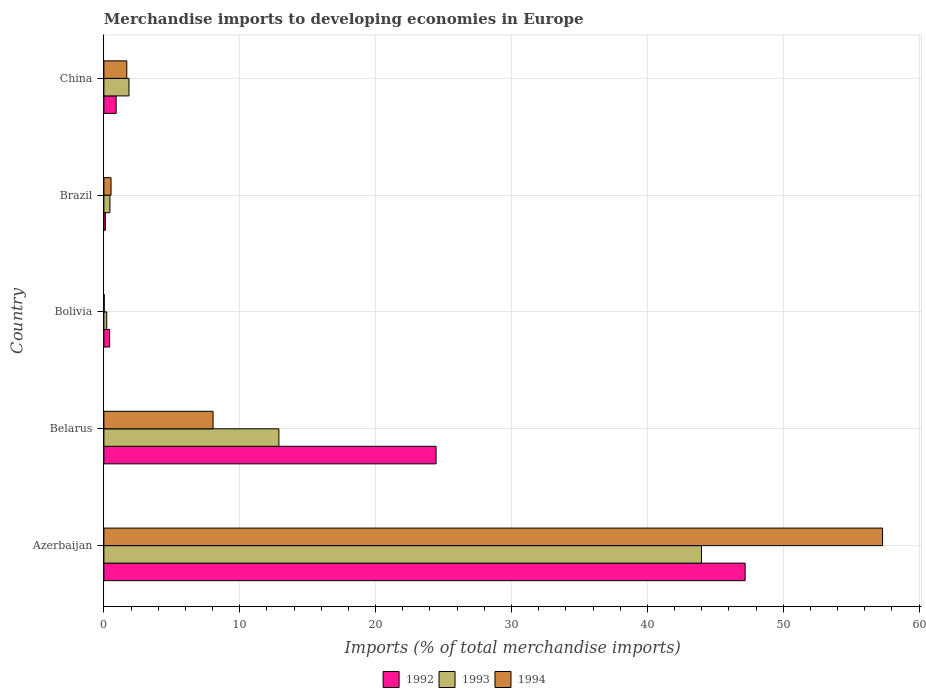How many groups of bars are there?
Provide a short and direct response. 5. How many bars are there on the 4th tick from the top?
Your answer should be compact. 3. What is the label of the 5th group of bars from the top?
Your answer should be very brief. Azerbaijan. In how many cases, is the number of bars for a given country not equal to the number of legend labels?
Your answer should be compact. 0. What is the percentage total merchandise imports in 1993 in Bolivia?
Provide a short and direct response. 0.21. Across all countries, what is the maximum percentage total merchandise imports in 1994?
Provide a succinct answer. 57.31. Across all countries, what is the minimum percentage total merchandise imports in 1992?
Offer a terse response. 0.11. In which country was the percentage total merchandise imports in 1993 maximum?
Your answer should be compact. Azerbaijan. What is the total percentage total merchandise imports in 1994 in the graph?
Give a very brief answer. 67.58. What is the difference between the percentage total merchandise imports in 1992 in Belarus and that in Brazil?
Give a very brief answer. 24.34. What is the difference between the percentage total merchandise imports in 1993 in Bolivia and the percentage total merchandise imports in 1994 in Brazil?
Your answer should be compact. -0.32. What is the average percentage total merchandise imports in 1992 per country?
Provide a short and direct response. 14.62. What is the difference between the percentage total merchandise imports in 1993 and percentage total merchandise imports in 1994 in Azerbaijan?
Your answer should be very brief. -13.33. In how many countries, is the percentage total merchandise imports in 1992 greater than 12 %?
Your response must be concise. 2. What is the ratio of the percentage total merchandise imports in 1994 in Azerbaijan to that in Belarus?
Provide a short and direct response. 7.13. Is the percentage total merchandise imports in 1994 in Bolivia less than that in China?
Give a very brief answer. Yes. What is the difference between the highest and the second highest percentage total merchandise imports in 1992?
Your answer should be very brief. 22.75. What is the difference between the highest and the lowest percentage total merchandise imports in 1994?
Ensure brevity in your answer.  57.29. In how many countries, is the percentage total merchandise imports in 1993 greater than the average percentage total merchandise imports in 1993 taken over all countries?
Give a very brief answer. 2. Is it the case that in every country, the sum of the percentage total merchandise imports in 1993 and percentage total merchandise imports in 1994 is greater than the percentage total merchandise imports in 1992?
Your answer should be very brief. No. How many bars are there?
Provide a succinct answer. 15. Does the graph contain any zero values?
Provide a succinct answer. No. Does the graph contain grids?
Keep it short and to the point. Yes. Where does the legend appear in the graph?
Provide a short and direct response. Bottom center. What is the title of the graph?
Provide a short and direct response. Merchandise imports to developing economies in Europe. Does "2007" appear as one of the legend labels in the graph?
Your response must be concise. No. What is the label or title of the X-axis?
Your answer should be compact. Imports (% of total merchandise imports). What is the Imports (% of total merchandise imports) in 1992 in Azerbaijan?
Ensure brevity in your answer.  47.2. What is the Imports (% of total merchandise imports) in 1993 in Azerbaijan?
Provide a short and direct response. 43.99. What is the Imports (% of total merchandise imports) in 1994 in Azerbaijan?
Ensure brevity in your answer.  57.31. What is the Imports (% of total merchandise imports) of 1992 in Belarus?
Provide a short and direct response. 24.45. What is the Imports (% of total merchandise imports) in 1993 in Belarus?
Make the answer very short. 12.88. What is the Imports (% of total merchandise imports) of 1994 in Belarus?
Ensure brevity in your answer.  8.04. What is the Imports (% of total merchandise imports) of 1992 in Bolivia?
Your answer should be compact. 0.42. What is the Imports (% of total merchandise imports) in 1993 in Bolivia?
Your answer should be very brief. 0.21. What is the Imports (% of total merchandise imports) of 1994 in Bolivia?
Ensure brevity in your answer.  0.02. What is the Imports (% of total merchandise imports) of 1992 in Brazil?
Provide a short and direct response. 0.11. What is the Imports (% of total merchandise imports) of 1993 in Brazil?
Offer a very short reply. 0.44. What is the Imports (% of total merchandise imports) of 1994 in Brazil?
Offer a terse response. 0.52. What is the Imports (% of total merchandise imports) of 1992 in China?
Your answer should be very brief. 0.9. What is the Imports (% of total merchandise imports) of 1993 in China?
Your answer should be compact. 1.85. What is the Imports (% of total merchandise imports) in 1994 in China?
Offer a very short reply. 1.68. Across all countries, what is the maximum Imports (% of total merchandise imports) of 1992?
Offer a very short reply. 47.2. Across all countries, what is the maximum Imports (% of total merchandise imports) of 1993?
Provide a short and direct response. 43.99. Across all countries, what is the maximum Imports (% of total merchandise imports) of 1994?
Provide a succinct answer. 57.31. Across all countries, what is the minimum Imports (% of total merchandise imports) in 1992?
Ensure brevity in your answer.  0.11. Across all countries, what is the minimum Imports (% of total merchandise imports) in 1993?
Make the answer very short. 0.21. Across all countries, what is the minimum Imports (% of total merchandise imports) in 1994?
Offer a terse response. 0.02. What is the total Imports (% of total merchandise imports) in 1992 in the graph?
Ensure brevity in your answer.  73.08. What is the total Imports (% of total merchandise imports) in 1993 in the graph?
Provide a succinct answer. 59.37. What is the total Imports (% of total merchandise imports) in 1994 in the graph?
Your response must be concise. 67.58. What is the difference between the Imports (% of total merchandise imports) in 1992 in Azerbaijan and that in Belarus?
Keep it short and to the point. 22.75. What is the difference between the Imports (% of total merchandise imports) of 1993 in Azerbaijan and that in Belarus?
Your response must be concise. 31.11. What is the difference between the Imports (% of total merchandise imports) of 1994 in Azerbaijan and that in Belarus?
Your answer should be compact. 49.28. What is the difference between the Imports (% of total merchandise imports) in 1992 in Azerbaijan and that in Bolivia?
Offer a very short reply. 46.78. What is the difference between the Imports (% of total merchandise imports) in 1993 in Azerbaijan and that in Bolivia?
Offer a very short reply. 43.78. What is the difference between the Imports (% of total merchandise imports) in 1994 in Azerbaijan and that in Bolivia?
Your response must be concise. 57.29. What is the difference between the Imports (% of total merchandise imports) of 1992 in Azerbaijan and that in Brazil?
Your response must be concise. 47.09. What is the difference between the Imports (% of total merchandise imports) in 1993 in Azerbaijan and that in Brazil?
Provide a succinct answer. 43.54. What is the difference between the Imports (% of total merchandise imports) of 1994 in Azerbaijan and that in Brazil?
Keep it short and to the point. 56.79. What is the difference between the Imports (% of total merchandise imports) of 1992 in Azerbaijan and that in China?
Your answer should be compact. 46.3. What is the difference between the Imports (% of total merchandise imports) in 1993 in Azerbaijan and that in China?
Offer a very short reply. 42.14. What is the difference between the Imports (% of total merchandise imports) of 1994 in Azerbaijan and that in China?
Provide a short and direct response. 55.63. What is the difference between the Imports (% of total merchandise imports) of 1992 in Belarus and that in Bolivia?
Provide a short and direct response. 24.03. What is the difference between the Imports (% of total merchandise imports) of 1993 in Belarus and that in Bolivia?
Keep it short and to the point. 12.67. What is the difference between the Imports (% of total merchandise imports) of 1994 in Belarus and that in Bolivia?
Ensure brevity in your answer.  8.01. What is the difference between the Imports (% of total merchandise imports) in 1992 in Belarus and that in Brazil?
Provide a short and direct response. 24.34. What is the difference between the Imports (% of total merchandise imports) of 1993 in Belarus and that in Brazil?
Offer a terse response. 12.44. What is the difference between the Imports (% of total merchandise imports) in 1994 in Belarus and that in Brazil?
Offer a terse response. 7.51. What is the difference between the Imports (% of total merchandise imports) in 1992 in Belarus and that in China?
Your answer should be compact. 23.55. What is the difference between the Imports (% of total merchandise imports) of 1993 in Belarus and that in China?
Your answer should be compact. 11.03. What is the difference between the Imports (% of total merchandise imports) in 1994 in Belarus and that in China?
Offer a terse response. 6.35. What is the difference between the Imports (% of total merchandise imports) of 1992 in Bolivia and that in Brazil?
Offer a very short reply. 0.32. What is the difference between the Imports (% of total merchandise imports) of 1993 in Bolivia and that in Brazil?
Offer a terse response. -0.24. What is the difference between the Imports (% of total merchandise imports) of 1994 in Bolivia and that in Brazil?
Your response must be concise. -0.5. What is the difference between the Imports (% of total merchandise imports) of 1992 in Bolivia and that in China?
Ensure brevity in your answer.  -0.48. What is the difference between the Imports (% of total merchandise imports) in 1993 in Bolivia and that in China?
Your response must be concise. -1.64. What is the difference between the Imports (% of total merchandise imports) in 1994 in Bolivia and that in China?
Give a very brief answer. -1.66. What is the difference between the Imports (% of total merchandise imports) in 1992 in Brazil and that in China?
Your answer should be compact. -0.8. What is the difference between the Imports (% of total merchandise imports) in 1993 in Brazil and that in China?
Offer a very short reply. -1.4. What is the difference between the Imports (% of total merchandise imports) in 1994 in Brazil and that in China?
Make the answer very short. -1.16. What is the difference between the Imports (% of total merchandise imports) in 1992 in Azerbaijan and the Imports (% of total merchandise imports) in 1993 in Belarus?
Keep it short and to the point. 34.32. What is the difference between the Imports (% of total merchandise imports) in 1992 in Azerbaijan and the Imports (% of total merchandise imports) in 1994 in Belarus?
Your answer should be compact. 39.16. What is the difference between the Imports (% of total merchandise imports) of 1993 in Azerbaijan and the Imports (% of total merchandise imports) of 1994 in Belarus?
Your answer should be very brief. 35.95. What is the difference between the Imports (% of total merchandise imports) in 1992 in Azerbaijan and the Imports (% of total merchandise imports) in 1993 in Bolivia?
Offer a very short reply. 46.99. What is the difference between the Imports (% of total merchandise imports) of 1992 in Azerbaijan and the Imports (% of total merchandise imports) of 1994 in Bolivia?
Offer a very short reply. 47.17. What is the difference between the Imports (% of total merchandise imports) in 1993 in Azerbaijan and the Imports (% of total merchandise imports) in 1994 in Bolivia?
Your response must be concise. 43.96. What is the difference between the Imports (% of total merchandise imports) of 1992 in Azerbaijan and the Imports (% of total merchandise imports) of 1993 in Brazil?
Your answer should be compact. 46.75. What is the difference between the Imports (% of total merchandise imports) of 1992 in Azerbaijan and the Imports (% of total merchandise imports) of 1994 in Brazil?
Offer a terse response. 46.67. What is the difference between the Imports (% of total merchandise imports) of 1993 in Azerbaijan and the Imports (% of total merchandise imports) of 1994 in Brazil?
Make the answer very short. 43.46. What is the difference between the Imports (% of total merchandise imports) of 1992 in Azerbaijan and the Imports (% of total merchandise imports) of 1993 in China?
Your response must be concise. 45.35. What is the difference between the Imports (% of total merchandise imports) in 1992 in Azerbaijan and the Imports (% of total merchandise imports) in 1994 in China?
Provide a succinct answer. 45.51. What is the difference between the Imports (% of total merchandise imports) of 1993 in Azerbaijan and the Imports (% of total merchandise imports) of 1994 in China?
Offer a very short reply. 42.3. What is the difference between the Imports (% of total merchandise imports) in 1992 in Belarus and the Imports (% of total merchandise imports) in 1993 in Bolivia?
Keep it short and to the point. 24.24. What is the difference between the Imports (% of total merchandise imports) of 1992 in Belarus and the Imports (% of total merchandise imports) of 1994 in Bolivia?
Your answer should be compact. 24.43. What is the difference between the Imports (% of total merchandise imports) in 1993 in Belarus and the Imports (% of total merchandise imports) in 1994 in Bolivia?
Provide a short and direct response. 12.86. What is the difference between the Imports (% of total merchandise imports) of 1992 in Belarus and the Imports (% of total merchandise imports) of 1993 in Brazil?
Ensure brevity in your answer.  24.01. What is the difference between the Imports (% of total merchandise imports) in 1992 in Belarus and the Imports (% of total merchandise imports) in 1994 in Brazil?
Offer a very short reply. 23.93. What is the difference between the Imports (% of total merchandise imports) in 1993 in Belarus and the Imports (% of total merchandise imports) in 1994 in Brazil?
Ensure brevity in your answer.  12.36. What is the difference between the Imports (% of total merchandise imports) of 1992 in Belarus and the Imports (% of total merchandise imports) of 1993 in China?
Offer a terse response. 22.6. What is the difference between the Imports (% of total merchandise imports) of 1992 in Belarus and the Imports (% of total merchandise imports) of 1994 in China?
Provide a short and direct response. 22.77. What is the difference between the Imports (% of total merchandise imports) in 1993 in Belarus and the Imports (% of total merchandise imports) in 1994 in China?
Give a very brief answer. 11.2. What is the difference between the Imports (% of total merchandise imports) of 1992 in Bolivia and the Imports (% of total merchandise imports) of 1993 in Brazil?
Offer a very short reply. -0.02. What is the difference between the Imports (% of total merchandise imports) of 1992 in Bolivia and the Imports (% of total merchandise imports) of 1994 in Brazil?
Your response must be concise. -0.1. What is the difference between the Imports (% of total merchandise imports) in 1993 in Bolivia and the Imports (% of total merchandise imports) in 1994 in Brazil?
Make the answer very short. -0.32. What is the difference between the Imports (% of total merchandise imports) of 1992 in Bolivia and the Imports (% of total merchandise imports) of 1993 in China?
Your answer should be compact. -1.42. What is the difference between the Imports (% of total merchandise imports) in 1992 in Bolivia and the Imports (% of total merchandise imports) in 1994 in China?
Provide a succinct answer. -1.26. What is the difference between the Imports (% of total merchandise imports) of 1993 in Bolivia and the Imports (% of total merchandise imports) of 1994 in China?
Your answer should be compact. -1.48. What is the difference between the Imports (% of total merchandise imports) in 1992 in Brazil and the Imports (% of total merchandise imports) in 1993 in China?
Offer a terse response. -1.74. What is the difference between the Imports (% of total merchandise imports) in 1992 in Brazil and the Imports (% of total merchandise imports) in 1994 in China?
Provide a short and direct response. -1.58. What is the difference between the Imports (% of total merchandise imports) of 1993 in Brazil and the Imports (% of total merchandise imports) of 1994 in China?
Provide a succinct answer. -1.24. What is the average Imports (% of total merchandise imports) in 1992 per country?
Provide a succinct answer. 14.62. What is the average Imports (% of total merchandise imports) of 1993 per country?
Your answer should be compact. 11.87. What is the average Imports (% of total merchandise imports) in 1994 per country?
Offer a terse response. 13.52. What is the difference between the Imports (% of total merchandise imports) in 1992 and Imports (% of total merchandise imports) in 1993 in Azerbaijan?
Make the answer very short. 3.21. What is the difference between the Imports (% of total merchandise imports) in 1992 and Imports (% of total merchandise imports) in 1994 in Azerbaijan?
Your response must be concise. -10.11. What is the difference between the Imports (% of total merchandise imports) in 1993 and Imports (% of total merchandise imports) in 1994 in Azerbaijan?
Provide a succinct answer. -13.33. What is the difference between the Imports (% of total merchandise imports) in 1992 and Imports (% of total merchandise imports) in 1993 in Belarus?
Ensure brevity in your answer.  11.57. What is the difference between the Imports (% of total merchandise imports) in 1992 and Imports (% of total merchandise imports) in 1994 in Belarus?
Give a very brief answer. 16.41. What is the difference between the Imports (% of total merchandise imports) of 1993 and Imports (% of total merchandise imports) of 1994 in Belarus?
Keep it short and to the point. 4.84. What is the difference between the Imports (% of total merchandise imports) of 1992 and Imports (% of total merchandise imports) of 1993 in Bolivia?
Offer a terse response. 0.22. What is the difference between the Imports (% of total merchandise imports) in 1992 and Imports (% of total merchandise imports) in 1994 in Bolivia?
Ensure brevity in your answer.  0.4. What is the difference between the Imports (% of total merchandise imports) of 1993 and Imports (% of total merchandise imports) of 1994 in Bolivia?
Your answer should be compact. 0.18. What is the difference between the Imports (% of total merchandise imports) of 1992 and Imports (% of total merchandise imports) of 1993 in Brazil?
Keep it short and to the point. -0.34. What is the difference between the Imports (% of total merchandise imports) of 1992 and Imports (% of total merchandise imports) of 1994 in Brazil?
Provide a succinct answer. -0.42. What is the difference between the Imports (% of total merchandise imports) of 1993 and Imports (% of total merchandise imports) of 1994 in Brazil?
Keep it short and to the point. -0.08. What is the difference between the Imports (% of total merchandise imports) of 1992 and Imports (% of total merchandise imports) of 1993 in China?
Your answer should be very brief. -0.94. What is the difference between the Imports (% of total merchandise imports) in 1992 and Imports (% of total merchandise imports) in 1994 in China?
Your response must be concise. -0.78. What is the difference between the Imports (% of total merchandise imports) of 1993 and Imports (% of total merchandise imports) of 1994 in China?
Keep it short and to the point. 0.16. What is the ratio of the Imports (% of total merchandise imports) in 1992 in Azerbaijan to that in Belarus?
Ensure brevity in your answer.  1.93. What is the ratio of the Imports (% of total merchandise imports) of 1993 in Azerbaijan to that in Belarus?
Your answer should be compact. 3.42. What is the ratio of the Imports (% of total merchandise imports) in 1994 in Azerbaijan to that in Belarus?
Your response must be concise. 7.13. What is the ratio of the Imports (% of total merchandise imports) of 1992 in Azerbaijan to that in Bolivia?
Provide a succinct answer. 111.66. What is the ratio of the Imports (% of total merchandise imports) in 1993 in Azerbaijan to that in Bolivia?
Provide a succinct answer. 212.06. What is the ratio of the Imports (% of total merchandise imports) of 1994 in Azerbaijan to that in Bolivia?
Provide a succinct answer. 2324.83. What is the ratio of the Imports (% of total merchandise imports) of 1992 in Azerbaijan to that in Brazil?
Keep it short and to the point. 439.5. What is the ratio of the Imports (% of total merchandise imports) in 1993 in Azerbaijan to that in Brazil?
Make the answer very short. 98.86. What is the ratio of the Imports (% of total merchandise imports) in 1994 in Azerbaijan to that in Brazil?
Keep it short and to the point. 109.17. What is the ratio of the Imports (% of total merchandise imports) in 1992 in Azerbaijan to that in China?
Keep it short and to the point. 52.3. What is the ratio of the Imports (% of total merchandise imports) in 1993 in Azerbaijan to that in China?
Give a very brief answer. 23.81. What is the ratio of the Imports (% of total merchandise imports) of 1994 in Azerbaijan to that in China?
Your response must be concise. 34.03. What is the ratio of the Imports (% of total merchandise imports) of 1992 in Belarus to that in Bolivia?
Your response must be concise. 57.84. What is the ratio of the Imports (% of total merchandise imports) of 1993 in Belarus to that in Bolivia?
Your response must be concise. 62.09. What is the ratio of the Imports (% of total merchandise imports) in 1994 in Belarus to that in Bolivia?
Provide a short and direct response. 326.01. What is the ratio of the Imports (% of total merchandise imports) of 1992 in Belarus to that in Brazil?
Make the answer very short. 227.68. What is the ratio of the Imports (% of total merchandise imports) of 1993 in Belarus to that in Brazil?
Your answer should be very brief. 28.95. What is the ratio of the Imports (% of total merchandise imports) of 1994 in Belarus to that in Brazil?
Your response must be concise. 15.31. What is the ratio of the Imports (% of total merchandise imports) in 1992 in Belarus to that in China?
Provide a short and direct response. 27.09. What is the ratio of the Imports (% of total merchandise imports) in 1993 in Belarus to that in China?
Offer a terse response. 6.97. What is the ratio of the Imports (% of total merchandise imports) in 1994 in Belarus to that in China?
Your answer should be compact. 4.77. What is the ratio of the Imports (% of total merchandise imports) of 1992 in Bolivia to that in Brazil?
Keep it short and to the point. 3.94. What is the ratio of the Imports (% of total merchandise imports) of 1993 in Bolivia to that in Brazil?
Offer a very short reply. 0.47. What is the ratio of the Imports (% of total merchandise imports) of 1994 in Bolivia to that in Brazil?
Your answer should be very brief. 0.05. What is the ratio of the Imports (% of total merchandise imports) in 1992 in Bolivia to that in China?
Give a very brief answer. 0.47. What is the ratio of the Imports (% of total merchandise imports) of 1993 in Bolivia to that in China?
Make the answer very short. 0.11. What is the ratio of the Imports (% of total merchandise imports) of 1994 in Bolivia to that in China?
Ensure brevity in your answer.  0.01. What is the ratio of the Imports (% of total merchandise imports) in 1992 in Brazil to that in China?
Your answer should be compact. 0.12. What is the ratio of the Imports (% of total merchandise imports) of 1993 in Brazil to that in China?
Your answer should be compact. 0.24. What is the ratio of the Imports (% of total merchandise imports) of 1994 in Brazil to that in China?
Offer a very short reply. 0.31. What is the difference between the highest and the second highest Imports (% of total merchandise imports) in 1992?
Offer a terse response. 22.75. What is the difference between the highest and the second highest Imports (% of total merchandise imports) of 1993?
Make the answer very short. 31.11. What is the difference between the highest and the second highest Imports (% of total merchandise imports) in 1994?
Ensure brevity in your answer.  49.28. What is the difference between the highest and the lowest Imports (% of total merchandise imports) in 1992?
Offer a terse response. 47.09. What is the difference between the highest and the lowest Imports (% of total merchandise imports) of 1993?
Offer a very short reply. 43.78. What is the difference between the highest and the lowest Imports (% of total merchandise imports) of 1994?
Offer a very short reply. 57.29. 